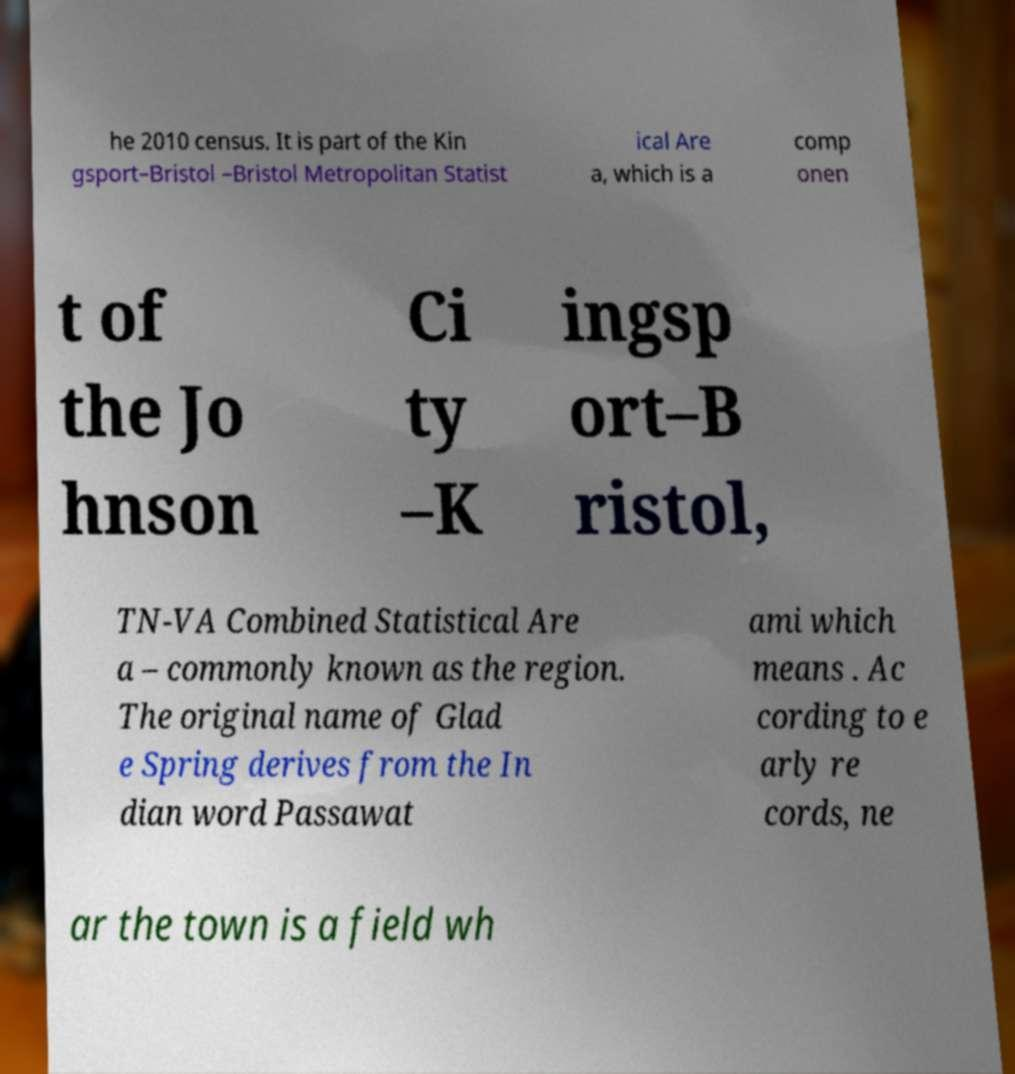Can you read and provide the text displayed in the image?This photo seems to have some interesting text. Can you extract and type it out for me? he 2010 census. It is part of the Kin gsport–Bristol –Bristol Metropolitan Statist ical Are a, which is a comp onen t of the Jo hnson Ci ty –K ingsp ort–B ristol, TN-VA Combined Statistical Are a – commonly known as the region. The original name of Glad e Spring derives from the In dian word Passawat ami which means . Ac cording to e arly re cords, ne ar the town is a field wh 